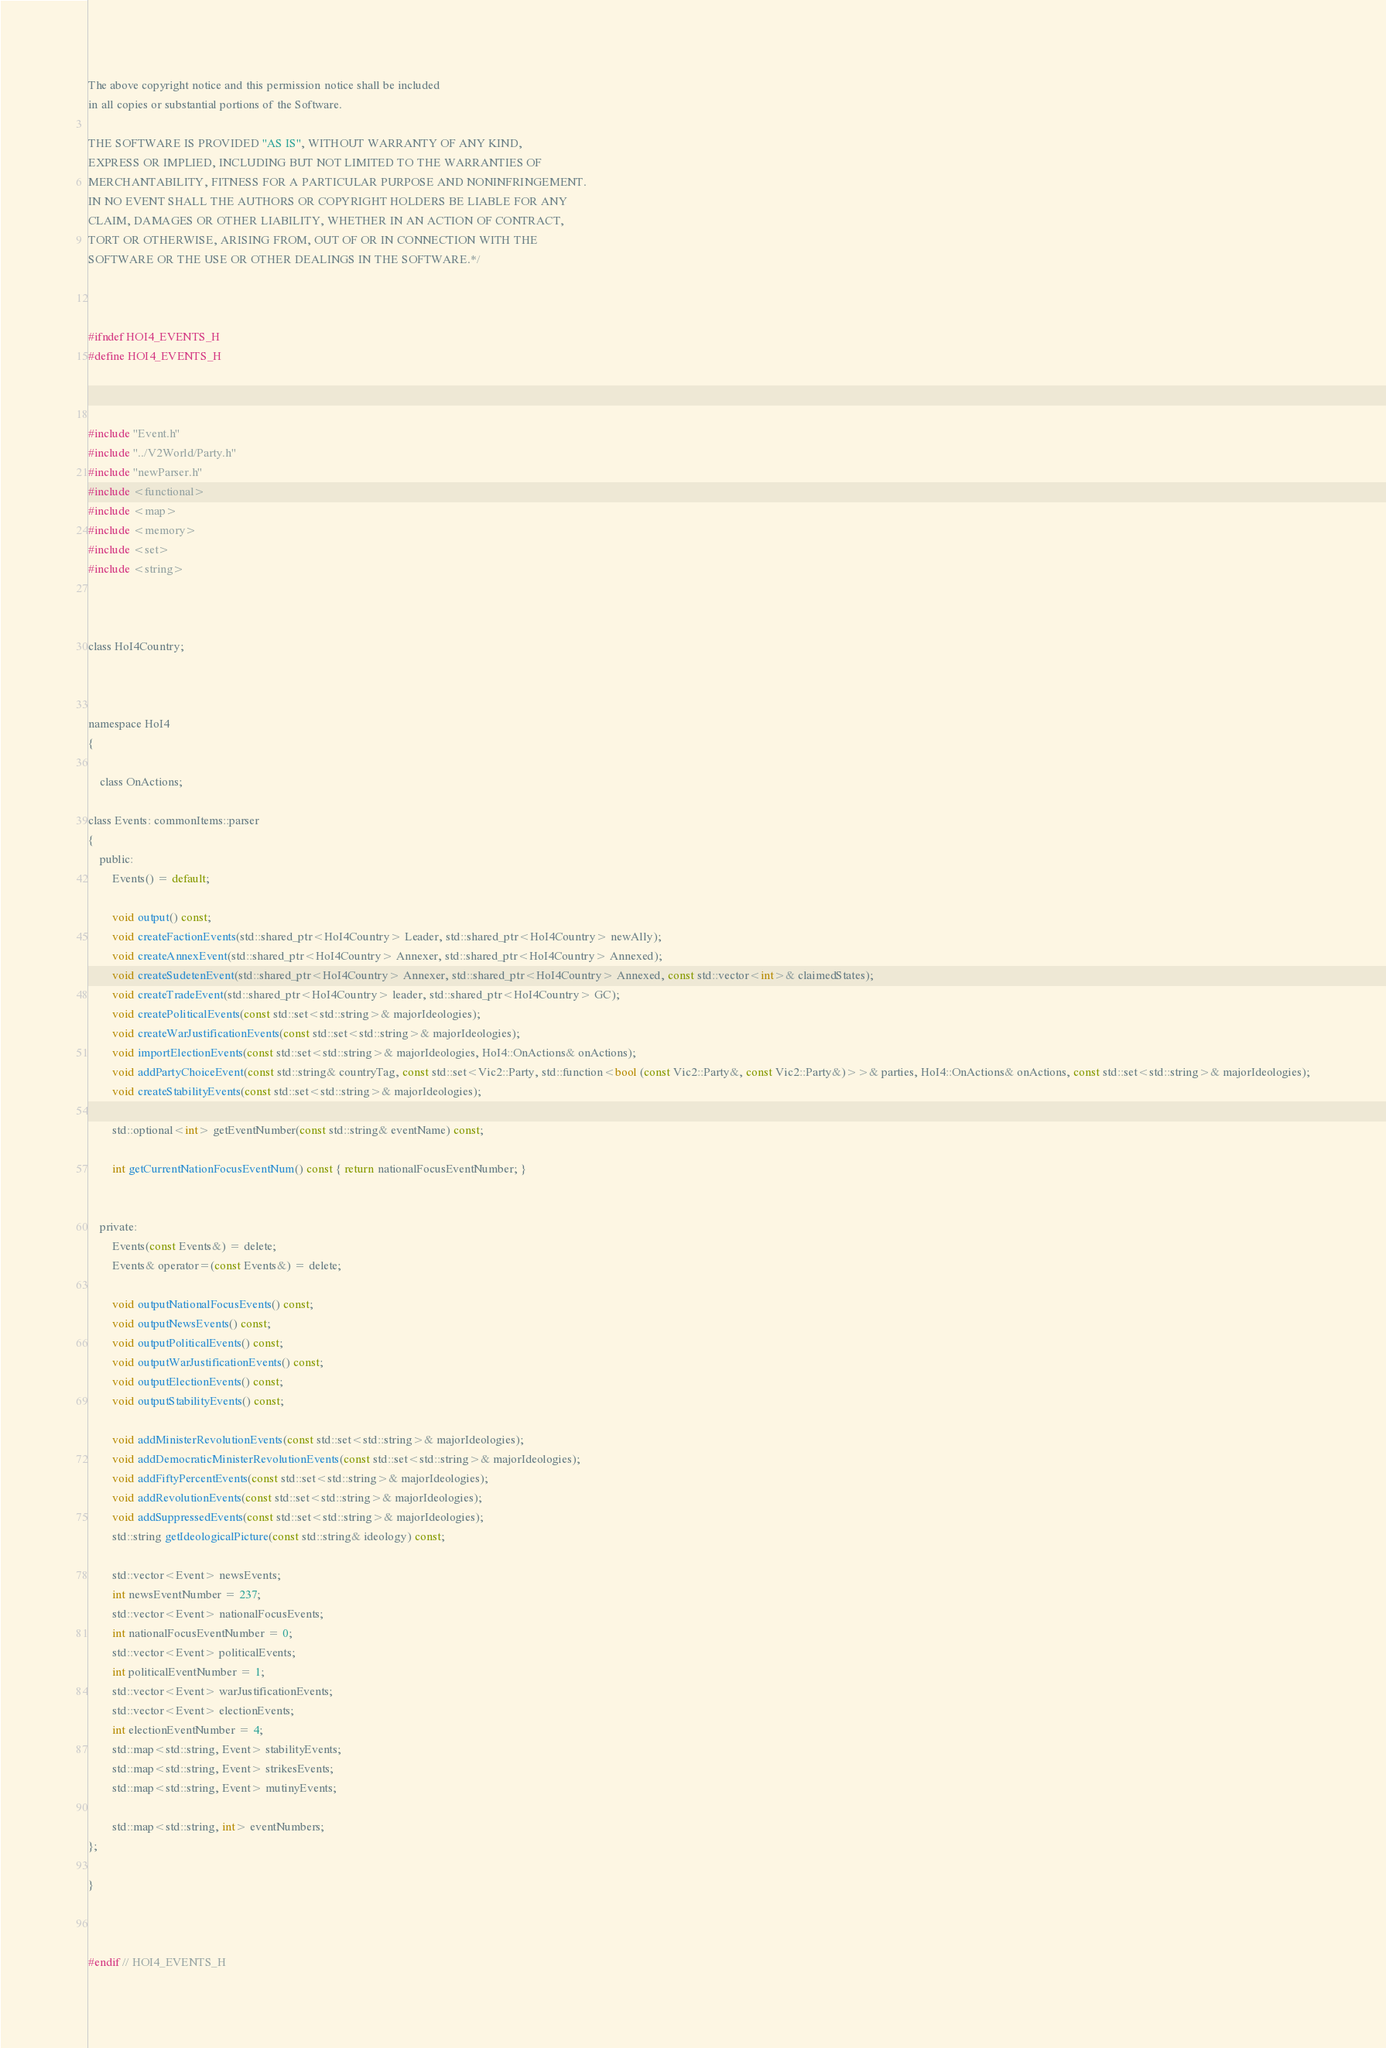<code> <loc_0><loc_0><loc_500><loc_500><_C_>
The above copyright notice and this permission notice shall be included
in all copies or substantial portions of the Software.

THE SOFTWARE IS PROVIDED "AS IS", WITHOUT WARRANTY OF ANY KIND,
EXPRESS OR IMPLIED, INCLUDING BUT NOT LIMITED TO THE WARRANTIES OF
MERCHANTABILITY, FITNESS FOR A PARTICULAR PURPOSE AND NONINFRINGEMENT.
IN NO EVENT SHALL THE AUTHORS OR COPYRIGHT HOLDERS BE LIABLE FOR ANY
CLAIM, DAMAGES OR OTHER LIABILITY, WHETHER IN AN ACTION OF CONTRACT,
TORT OR OTHERWISE, ARISING FROM, OUT OF OR IN CONNECTION WITH THE
SOFTWARE OR THE USE OR OTHER DEALINGS IN THE SOFTWARE.*/



#ifndef HOI4_EVENTS_H
#define HOI4_EVENTS_H



#include "Event.h"
#include "../V2World/Party.h"
#include "newParser.h"
#include <functional>
#include <map>
#include <memory>
#include <set>
#include <string>



class HoI4Country;



namespace HoI4
{

	class OnActions;

class Events: commonItems::parser
{
	public:
		Events() = default;

		void output() const;
		void createFactionEvents(std::shared_ptr<HoI4Country> Leader, std::shared_ptr<HoI4Country> newAlly);
		void createAnnexEvent(std::shared_ptr<HoI4Country> Annexer, std::shared_ptr<HoI4Country> Annexed);
		void createSudetenEvent(std::shared_ptr<HoI4Country> Annexer, std::shared_ptr<HoI4Country> Annexed, const std::vector<int>& claimedStates);
		void createTradeEvent(std::shared_ptr<HoI4Country> leader, std::shared_ptr<HoI4Country> GC);
		void createPoliticalEvents(const std::set<std::string>& majorIdeologies);
		void createWarJustificationEvents(const std::set<std::string>& majorIdeologies);
		void importElectionEvents(const std::set<std::string>& majorIdeologies, HoI4::OnActions& onActions);
		void addPartyChoiceEvent(const std::string& countryTag, const std::set<Vic2::Party, std::function<bool (const Vic2::Party&, const Vic2::Party&)>>& parties, HoI4::OnActions& onActions, const std::set<std::string>& majorIdeologies);
		void createStabilityEvents(const std::set<std::string>& majorIdeologies);

		std::optional<int> getEventNumber(const std::string& eventName) const;

		int getCurrentNationFocusEventNum() const { return nationalFocusEventNumber; }


	private:
		Events(const Events&) = delete;
		Events& operator=(const Events&) = delete;

		void outputNationalFocusEvents() const;
		void outputNewsEvents() const;
		void outputPoliticalEvents() const;
		void outputWarJustificationEvents() const;
		void outputElectionEvents() const;
		void outputStabilityEvents() const;

		void addMinisterRevolutionEvents(const std::set<std::string>& majorIdeologies);
		void addDemocraticMinisterRevolutionEvents(const std::set<std::string>& majorIdeologies);
		void addFiftyPercentEvents(const std::set<std::string>& majorIdeologies);
		void addRevolutionEvents(const std::set<std::string>& majorIdeologies);
		void addSuppressedEvents(const std::set<std::string>& majorIdeologies);
		std::string getIdeologicalPicture(const std::string& ideology) const;

		std::vector<Event> newsEvents;
		int newsEventNumber = 237;
		std::vector<Event> nationalFocusEvents;
		int nationalFocusEventNumber = 0;
		std::vector<Event> politicalEvents;
		int politicalEventNumber = 1;
		std::vector<Event> warJustificationEvents;
		std::vector<Event> electionEvents;
		int electionEventNumber = 4;
		std::map<std::string, Event> stabilityEvents;
		std::map<std::string, Event> strikesEvents;
		std::map<std::string, Event> mutinyEvents;

		std::map<std::string, int> eventNumbers;
};

}



#endif // HOI4_EVENTS_H</code> 